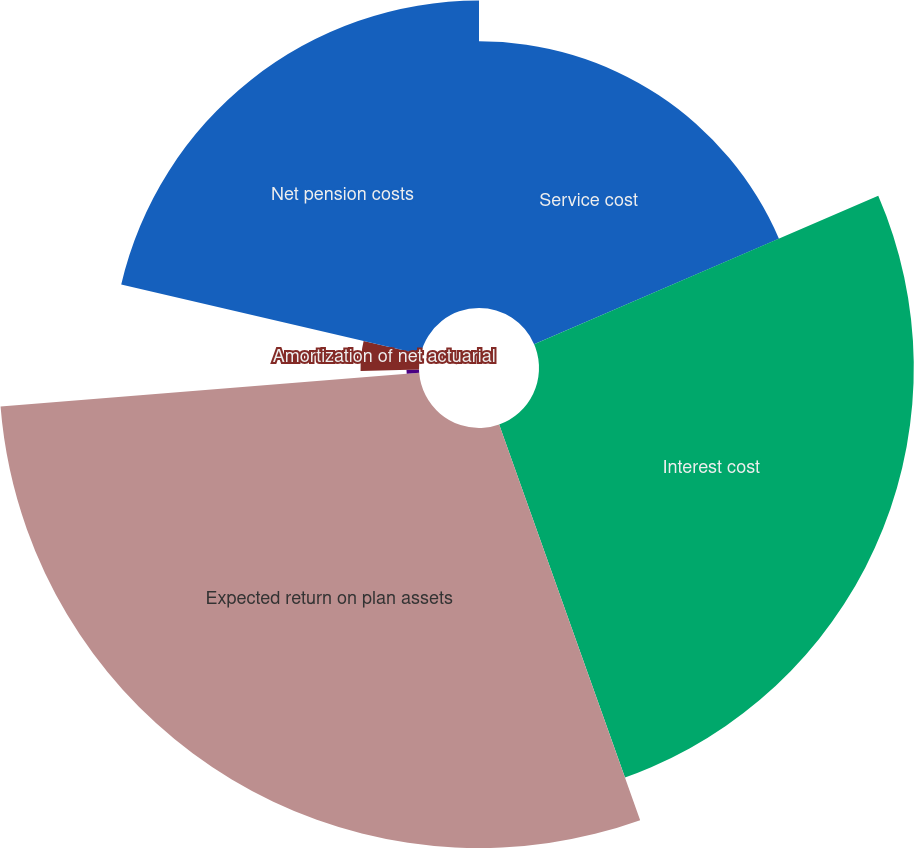Convert chart. <chart><loc_0><loc_0><loc_500><loc_500><pie_chart><fcel>Service cost<fcel>Interest cost<fcel>Expected return on plan assets<fcel>Amortization of prior service<fcel>Amortization of net actuarial<fcel>Net pension costs<nl><fcel>18.52%<fcel>26.03%<fcel>29.17%<fcel>0.87%<fcel>4.06%<fcel>21.35%<nl></chart> 